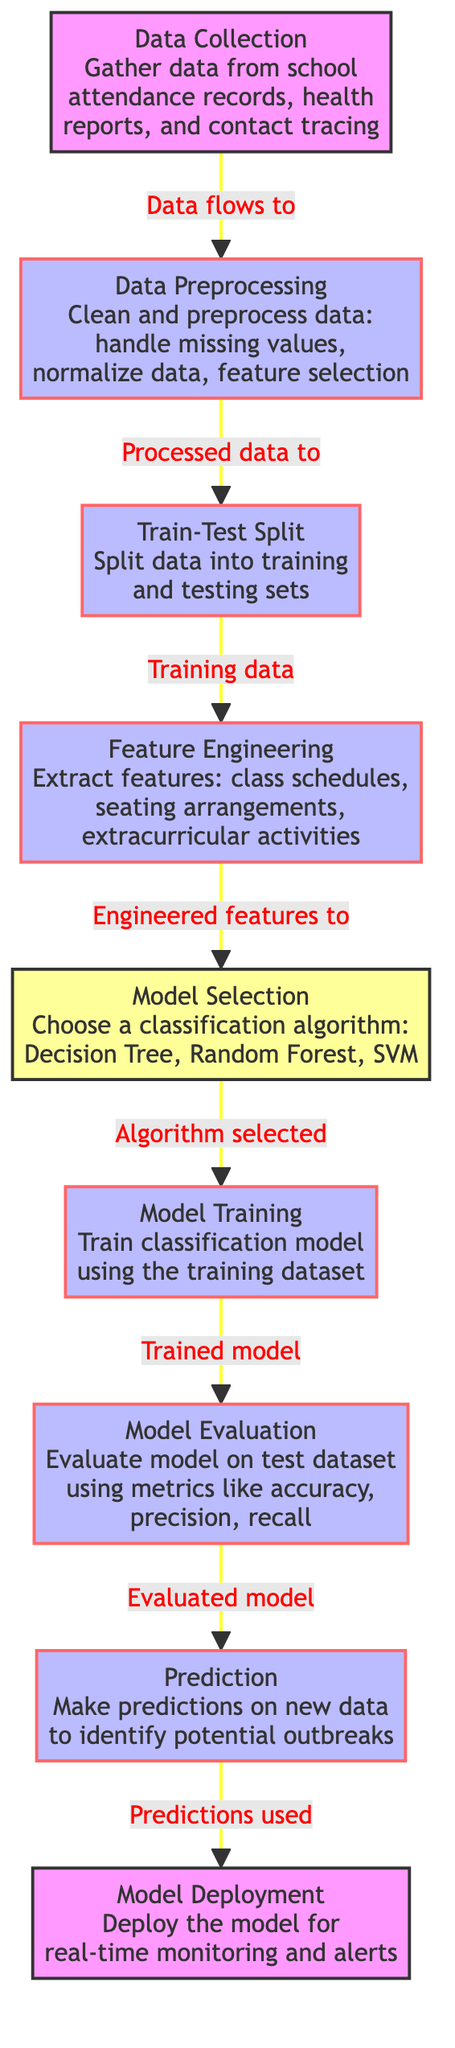What is the first step in the process? The diagram starts with the "Data Collection" node, indicating it is the initial step before any other actions take place.
Answer: Data Collection How many main process steps are there in the diagram? By counting the labeled process nodes, we find there are five major steps, which are Data Preprocessing, Train-Test Split, Feature Engineering, Model Training, and Model Evaluation.
Answer: Five Which node follows Model Selection? According to the flow of the diagram, the "Model Training" node immediately follows "Model Selection," indicating that after choosing a classification algorithm, the next step is training the model.
Answer: Model Training What is the final step in the process according to the diagram? The last node listed in the flow is "Model Deployment," showing that the ultimate goal is to deploy the model for real-time monitoring and alerts after making predictions.
Answer: Model Deployment How does the data flow after Data Preprocessing? After "Data Preprocessing" in the diagram, the data moves to "Train-Test Split," indicating that processed data is divided into training and testing sets next.
Answer: Train-Test Split What classification algorithms are available for selection? The algorithms listed in the diagram under "Model Selection" include Decision Tree, Random Forest, and SVM, showcasing the options available for model training.
Answer: Decision Tree, Random Forest, SVM What is the purpose of the Prediction node? The "Prediction" node's purpose is to make predictions on new data, specifically to identify potential outbreaks based on the trained model.
Answer: Identify potential outbreaks What comes after Model Evaluation in the process? After "Model Evaluation," the process moves to "Prediction," which involves utilizing the evaluated model to make further predictions.
Answer: Prediction What is the role of Feature Engineering in the process? The purpose of "Feature Engineering" is to extract relevant features like class schedules, seating arrangements, and extracurricular activities from the training data, which are crucial for the classification algorithm.
Answer: Extract relevant features 